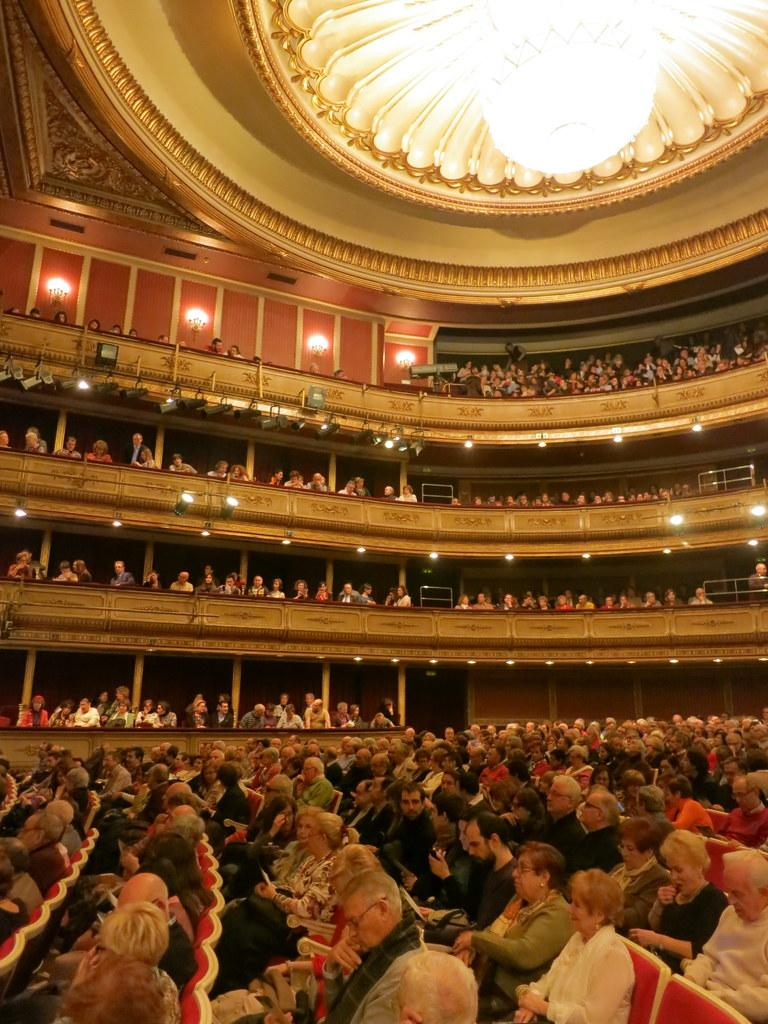What is the main subject of the image? The main subject of the image is a group of people. What are some of the people in the image doing? Some people are sitting on chairs, while others are standing. Where is the image taken? The image is an inside view of a building. How many visitors can be seen in the image? There is no mention of visitors in the image; it simply shows a group of people. What type of vest is being worn by the person in the image? There is no person wearing a vest in the image. 